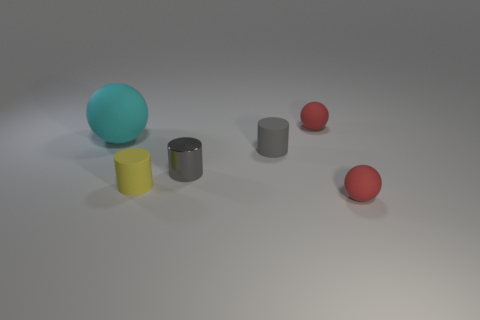Are there any other things that are the same size as the cyan ball?
Ensure brevity in your answer.  No. What is the color of the tiny matte thing that is in front of the large cyan thing and behind the tiny yellow cylinder?
Your answer should be compact. Gray. Is there anything else that has the same color as the small shiny object?
Your response must be concise. Yes. The matte thing that is in front of the small yellow object that is on the left side of the metal thing is what color?
Your answer should be compact. Red. Do the yellow matte cylinder and the cyan matte object have the same size?
Give a very brief answer. No. Do the tiny yellow cylinder on the right side of the large object and the red thing that is in front of the cyan sphere have the same material?
Your answer should be compact. Yes. There is a small yellow thing to the left of the tiny matte ball that is behind the red matte ball in front of the small gray metallic cylinder; what shape is it?
Provide a short and direct response. Cylinder. Are there more small red balls than small cylinders?
Keep it short and to the point. No. Are there any spheres?
Your response must be concise. Yes. What number of things are either balls to the right of the yellow cylinder or tiny matte spheres that are behind the large cyan object?
Offer a very short reply. 2. 